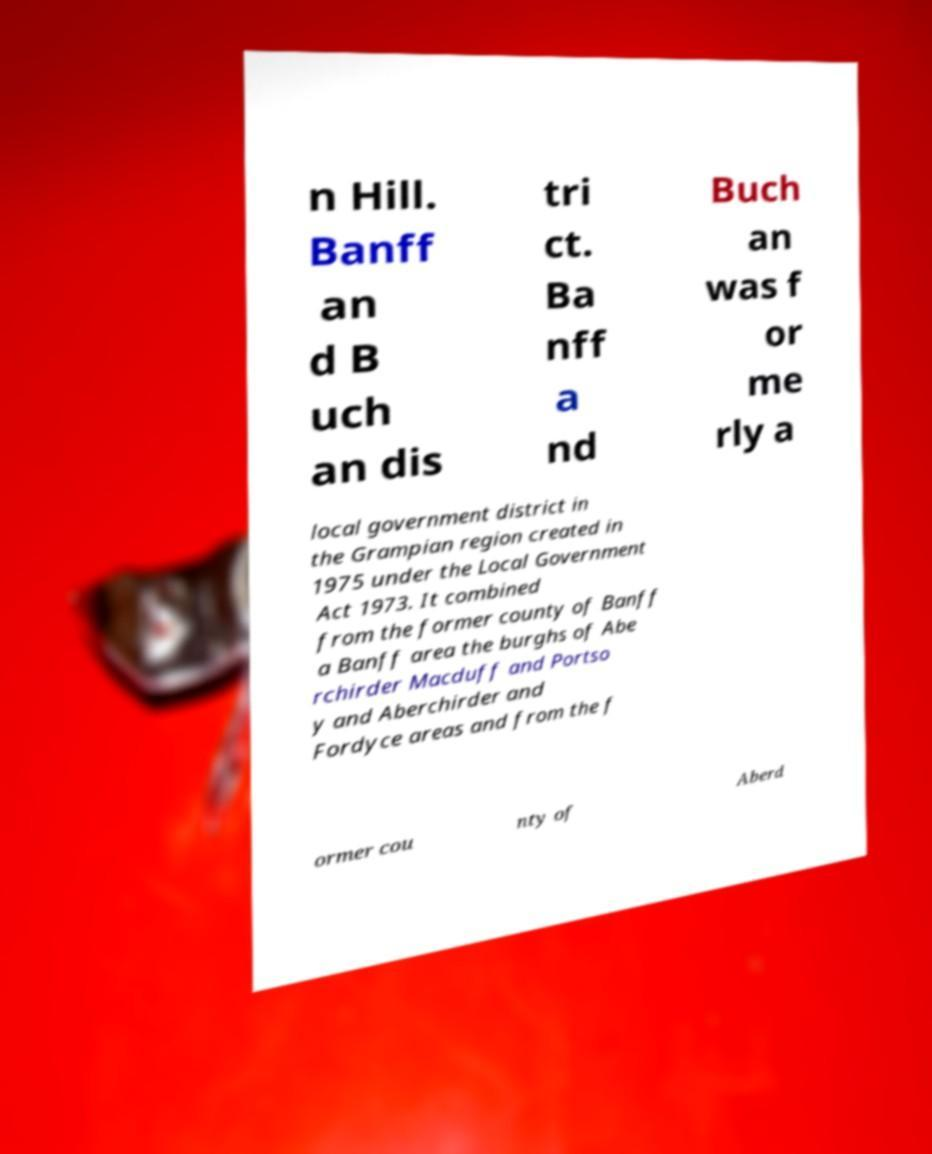I need the written content from this picture converted into text. Can you do that? n Hill. Banff an d B uch an dis tri ct. Ba nff a nd Buch an was f or me rly a local government district in the Grampian region created in 1975 under the Local Government Act 1973. It combined from the former county of Banff a Banff area the burghs of Abe rchirder Macduff and Portso y and Aberchirder and Fordyce areas and from the f ormer cou nty of Aberd 